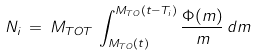<formula> <loc_0><loc_0><loc_500><loc_500>N _ { i } \, = \, M _ { T O T } \, \int _ { M _ { T O } ( t ) } ^ { M _ { T O } ( t - T _ { i } ) } \frac { \Phi ( m ) } { m } \, d m</formula> 